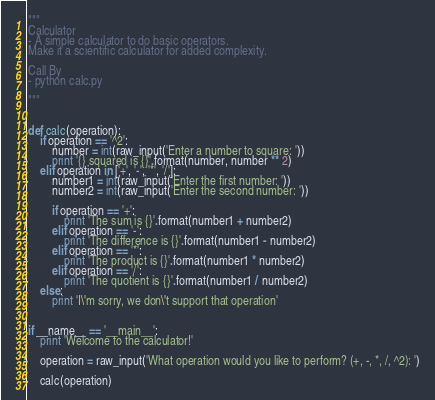Convert code to text. <code><loc_0><loc_0><loc_500><loc_500><_Python_>"""
Calculator
- A simple calculator to do basic operators.
Make it a scientific calculator for added complexity.

Call By
- python calc.py

"""


def calc(operation):
    if operation == '^2':
        number = int(raw_input('Enter a number to square: '))
        print '{} squared is {}'.format(number, number ** 2)
    elif operation in ['+', '-', '*', '/']:
        number1 = int(raw_input('Enter the first number: '))
        number2 = int(raw_input('Enter the second number: '))

        if operation == '+':
            print 'The sum is {}'.format(number1 + number2)
        elif operation == '-':
            print 'The difference is {}'.format(number1 - number2)
        elif operation == '*':
            print 'The product is {}'.format(number1 * number2)
        elif operation == '/':
            print 'The quotient is {}'.format(number1 / number2)
    else:
        print 'I\'m sorry, we don\'t support that operation'


if __name__ == '__main__':
    print 'Welcome to the calculator!'

    operation = raw_input('What operation would you like to perform? (+, -, *, /, ^2): ')

    calc(operation)
</code> 